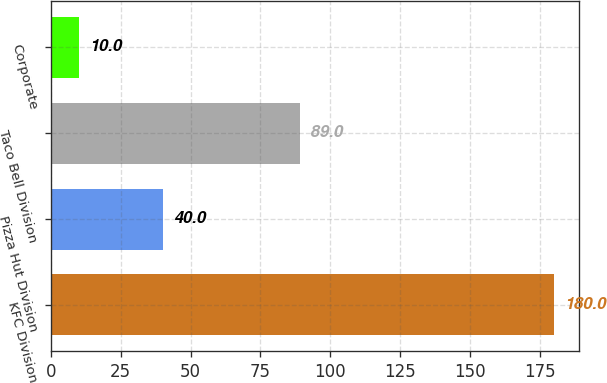Convert chart. <chart><loc_0><loc_0><loc_500><loc_500><bar_chart><fcel>KFC Division<fcel>Pizza Hut Division<fcel>Taco Bell Division<fcel>Corporate<nl><fcel>180<fcel>40<fcel>89<fcel>10<nl></chart> 